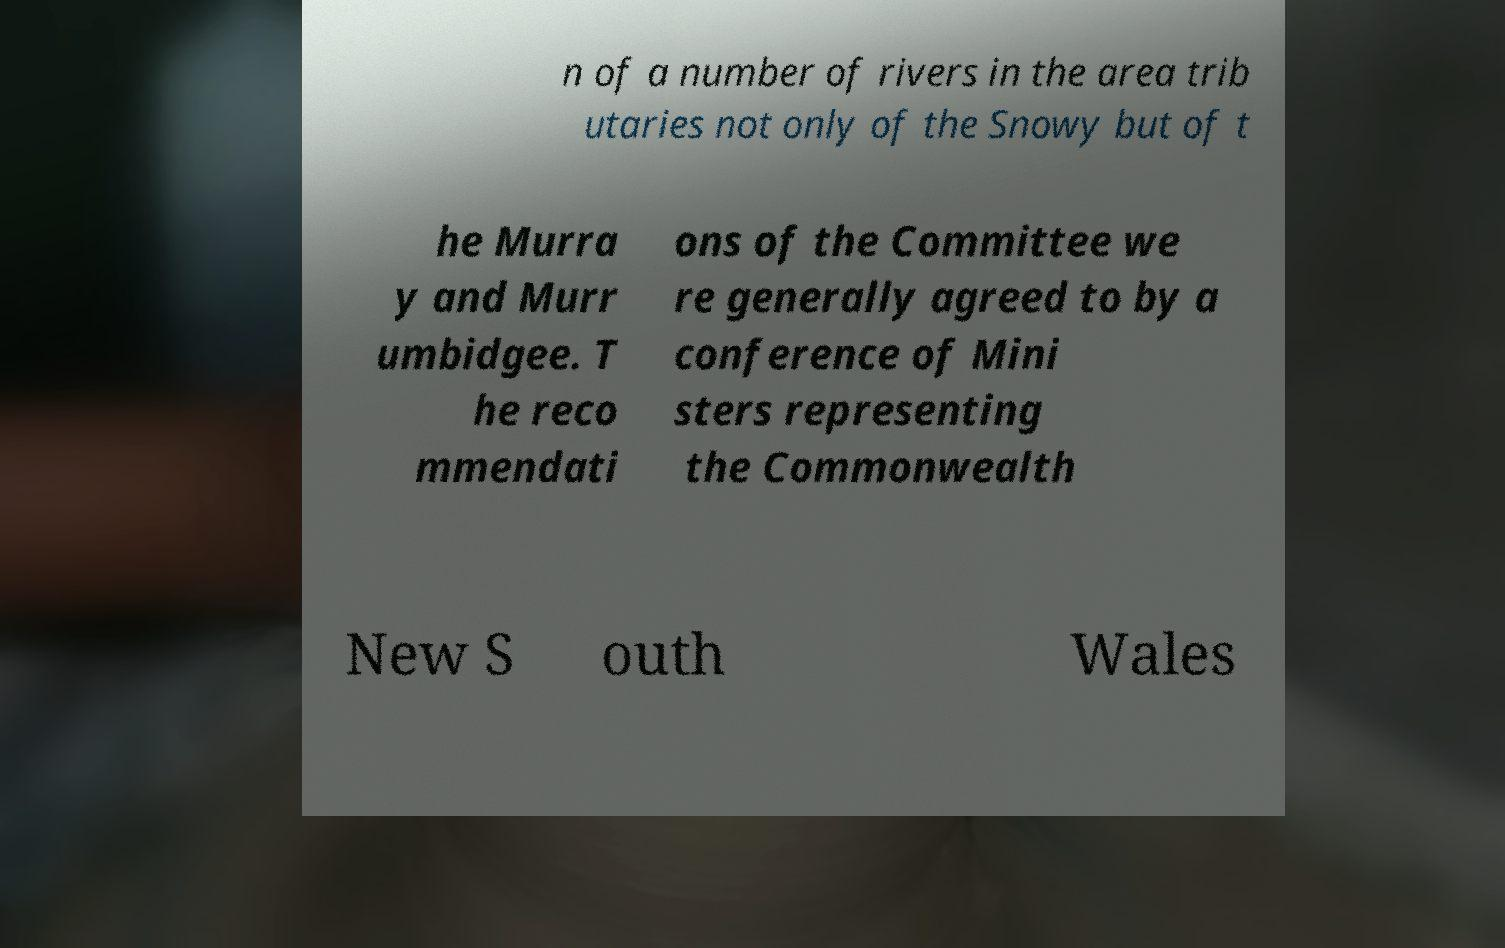Please identify and transcribe the text found in this image. n of a number of rivers in the area trib utaries not only of the Snowy but of t he Murra y and Murr umbidgee. T he reco mmendati ons of the Committee we re generally agreed to by a conference of Mini sters representing the Commonwealth New S outh Wales 